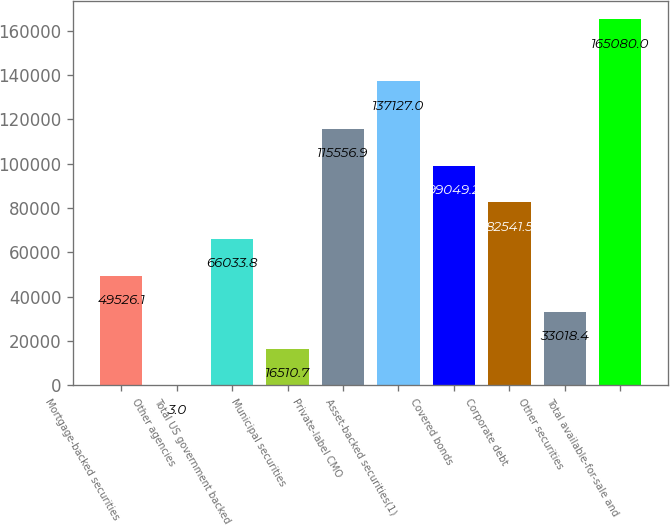Convert chart. <chart><loc_0><loc_0><loc_500><loc_500><bar_chart><fcel>Mortgage-backed securities<fcel>Other agencies<fcel>Total US government backed<fcel>Municipal securities<fcel>Private-label CMO<fcel>Asset-backed securities(1)<fcel>Covered bonds<fcel>Corporate debt<fcel>Other securities<fcel>Total available-for-sale and<nl><fcel>49526.1<fcel>3<fcel>66033.8<fcel>16510.7<fcel>115557<fcel>137127<fcel>99049.2<fcel>82541.5<fcel>33018.4<fcel>165080<nl></chart> 